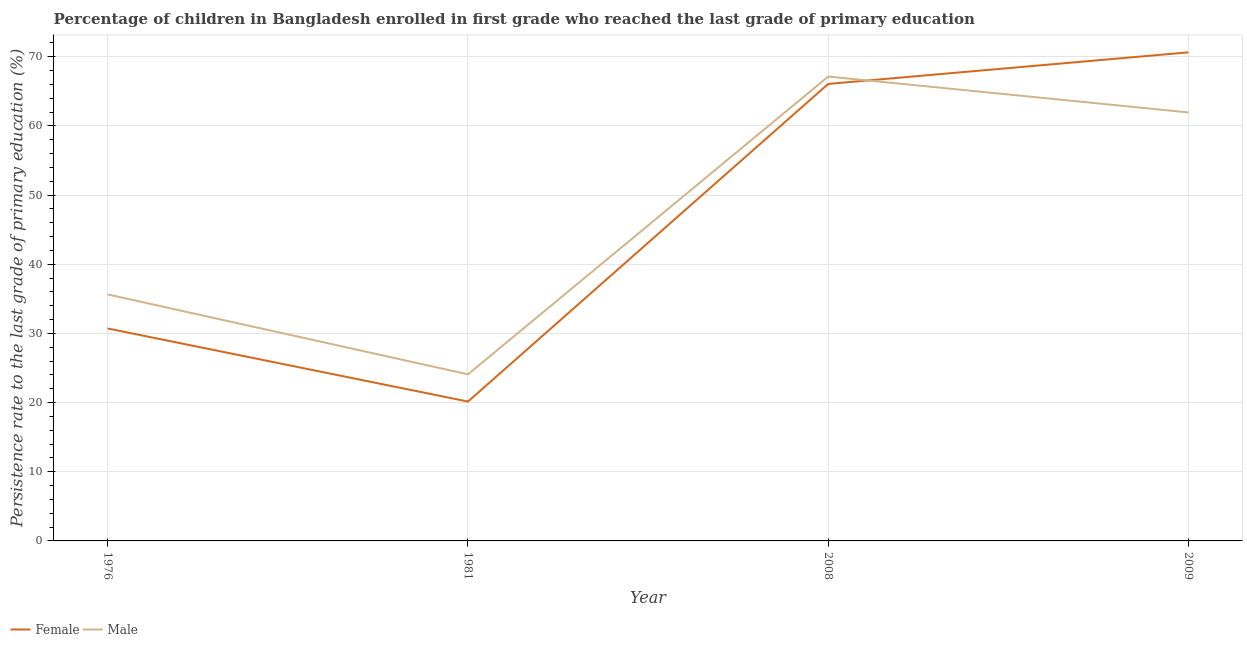How many different coloured lines are there?
Provide a succinct answer. 2. Does the line corresponding to persistence rate of male students intersect with the line corresponding to persistence rate of female students?
Your answer should be compact. Yes. What is the persistence rate of male students in 2008?
Offer a terse response. 67.14. Across all years, what is the maximum persistence rate of male students?
Your answer should be compact. 67.14. Across all years, what is the minimum persistence rate of male students?
Offer a terse response. 24.09. In which year was the persistence rate of male students maximum?
Make the answer very short. 2008. What is the total persistence rate of female students in the graph?
Keep it short and to the point. 187.57. What is the difference between the persistence rate of female students in 1976 and that in 1981?
Your answer should be very brief. 10.57. What is the difference between the persistence rate of female students in 1976 and the persistence rate of male students in 2008?
Your answer should be very brief. -36.42. What is the average persistence rate of female students per year?
Offer a terse response. 46.89. In the year 2008, what is the difference between the persistence rate of male students and persistence rate of female students?
Make the answer very short. 1.07. What is the ratio of the persistence rate of male students in 1976 to that in 1981?
Your response must be concise. 1.48. What is the difference between the highest and the second highest persistence rate of male students?
Provide a succinct answer. 5.19. What is the difference between the highest and the lowest persistence rate of male students?
Your answer should be compact. 43.05. Is the sum of the persistence rate of male students in 1976 and 2008 greater than the maximum persistence rate of female students across all years?
Your answer should be compact. Yes. Is the persistence rate of female students strictly greater than the persistence rate of male students over the years?
Your response must be concise. No. Where does the legend appear in the graph?
Offer a very short reply. Bottom left. How many legend labels are there?
Keep it short and to the point. 2. What is the title of the graph?
Offer a terse response. Percentage of children in Bangladesh enrolled in first grade who reached the last grade of primary education. Does "Malaria" appear as one of the legend labels in the graph?
Ensure brevity in your answer.  No. What is the label or title of the Y-axis?
Provide a short and direct response. Persistence rate to the last grade of primary education (%). What is the Persistence rate to the last grade of primary education (%) in Female in 1976?
Provide a short and direct response. 30.71. What is the Persistence rate to the last grade of primary education (%) of Male in 1976?
Ensure brevity in your answer.  35.64. What is the Persistence rate to the last grade of primary education (%) in Female in 1981?
Give a very brief answer. 20.15. What is the Persistence rate to the last grade of primary education (%) in Male in 1981?
Provide a succinct answer. 24.09. What is the Persistence rate to the last grade of primary education (%) in Female in 2008?
Your answer should be compact. 66.07. What is the Persistence rate to the last grade of primary education (%) of Male in 2008?
Make the answer very short. 67.14. What is the Persistence rate to the last grade of primary education (%) of Female in 2009?
Ensure brevity in your answer.  70.64. What is the Persistence rate to the last grade of primary education (%) of Male in 2009?
Offer a very short reply. 61.95. Across all years, what is the maximum Persistence rate to the last grade of primary education (%) of Female?
Your answer should be very brief. 70.64. Across all years, what is the maximum Persistence rate to the last grade of primary education (%) in Male?
Keep it short and to the point. 67.14. Across all years, what is the minimum Persistence rate to the last grade of primary education (%) of Female?
Provide a succinct answer. 20.15. Across all years, what is the minimum Persistence rate to the last grade of primary education (%) of Male?
Give a very brief answer. 24.09. What is the total Persistence rate to the last grade of primary education (%) in Female in the graph?
Ensure brevity in your answer.  187.57. What is the total Persistence rate to the last grade of primary education (%) of Male in the graph?
Ensure brevity in your answer.  188.81. What is the difference between the Persistence rate to the last grade of primary education (%) in Female in 1976 and that in 1981?
Offer a very short reply. 10.57. What is the difference between the Persistence rate to the last grade of primary education (%) in Male in 1976 and that in 1981?
Provide a succinct answer. 11.55. What is the difference between the Persistence rate to the last grade of primary education (%) in Female in 1976 and that in 2008?
Provide a succinct answer. -35.36. What is the difference between the Persistence rate to the last grade of primary education (%) of Male in 1976 and that in 2008?
Provide a short and direct response. -31.5. What is the difference between the Persistence rate to the last grade of primary education (%) in Female in 1976 and that in 2009?
Your answer should be very brief. -39.92. What is the difference between the Persistence rate to the last grade of primary education (%) of Male in 1976 and that in 2009?
Keep it short and to the point. -26.31. What is the difference between the Persistence rate to the last grade of primary education (%) of Female in 1981 and that in 2008?
Your answer should be compact. -45.92. What is the difference between the Persistence rate to the last grade of primary education (%) in Male in 1981 and that in 2008?
Keep it short and to the point. -43.05. What is the difference between the Persistence rate to the last grade of primary education (%) in Female in 1981 and that in 2009?
Keep it short and to the point. -50.49. What is the difference between the Persistence rate to the last grade of primary education (%) in Male in 1981 and that in 2009?
Offer a terse response. -37.86. What is the difference between the Persistence rate to the last grade of primary education (%) of Female in 2008 and that in 2009?
Provide a succinct answer. -4.57. What is the difference between the Persistence rate to the last grade of primary education (%) of Male in 2008 and that in 2009?
Your answer should be very brief. 5.19. What is the difference between the Persistence rate to the last grade of primary education (%) in Female in 1976 and the Persistence rate to the last grade of primary education (%) in Male in 1981?
Offer a terse response. 6.63. What is the difference between the Persistence rate to the last grade of primary education (%) in Female in 1976 and the Persistence rate to the last grade of primary education (%) in Male in 2008?
Your response must be concise. -36.42. What is the difference between the Persistence rate to the last grade of primary education (%) of Female in 1976 and the Persistence rate to the last grade of primary education (%) of Male in 2009?
Offer a terse response. -31.24. What is the difference between the Persistence rate to the last grade of primary education (%) of Female in 1981 and the Persistence rate to the last grade of primary education (%) of Male in 2008?
Offer a very short reply. -46.99. What is the difference between the Persistence rate to the last grade of primary education (%) of Female in 1981 and the Persistence rate to the last grade of primary education (%) of Male in 2009?
Your answer should be very brief. -41.8. What is the difference between the Persistence rate to the last grade of primary education (%) in Female in 2008 and the Persistence rate to the last grade of primary education (%) in Male in 2009?
Make the answer very short. 4.12. What is the average Persistence rate to the last grade of primary education (%) in Female per year?
Your response must be concise. 46.89. What is the average Persistence rate to the last grade of primary education (%) in Male per year?
Offer a terse response. 47.2. In the year 1976, what is the difference between the Persistence rate to the last grade of primary education (%) of Female and Persistence rate to the last grade of primary education (%) of Male?
Your response must be concise. -4.92. In the year 1981, what is the difference between the Persistence rate to the last grade of primary education (%) in Female and Persistence rate to the last grade of primary education (%) in Male?
Provide a succinct answer. -3.94. In the year 2008, what is the difference between the Persistence rate to the last grade of primary education (%) of Female and Persistence rate to the last grade of primary education (%) of Male?
Give a very brief answer. -1.07. In the year 2009, what is the difference between the Persistence rate to the last grade of primary education (%) of Female and Persistence rate to the last grade of primary education (%) of Male?
Provide a succinct answer. 8.69. What is the ratio of the Persistence rate to the last grade of primary education (%) of Female in 1976 to that in 1981?
Make the answer very short. 1.52. What is the ratio of the Persistence rate to the last grade of primary education (%) of Male in 1976 to that in 1981?
Make the answer very short. 1.48. What is the ratio of the Persistence rate to the last grade of primary education (%) of Female in 1976 to that in 2008?
Keep it short and to the point. 0.46. What is the ratio of the Persistence rate to the last grade of primary education (%) in Male in 1976 to that in 2008?
Keep it short and to the point. 0.53. What is the ratio of the Persistence rate to the last grade of primary education (%) in Female in 1976 to that in 2009?
Your response must be concise. 0.43. What is the ratio of the Persistence rate to the last grade of primary education (%) in Male in 1976 to that in 2009?
Your answer should be compact. 0.58. What is the ratio of the Persistence rate to the last grade of primary education (%) of Female in 1981 to that in 2008?
Provide a short and direct response. 0.3. What is the ratio of the Persistence rate to the last grade of primary education (%) in Male in 1981 to that in 2008?
Offer a terse response. 0.36. What is the ratio of the Persistence rate to the last grade of primary education (%) of Female in 1981 to that in 2009?
Keep it short and to the point. 0.29. What is the ratio of the Persistence rate to the last grade of primary education (%) of Male in 1981 to that in 2009?
Your answer should be compact. 0.39. What is the ratio of the Persistence rate to the last grade of primary education (%) of Female in 2008 to that in 2009?
Your response must be concise. 0.94. What is the ratio of the Persistence rate to the last grade of primary education (%) of Male in 2008 to that in 2009?
Provide a succinct answer. 1.08. What is the difference between the highest and the second highest Persistence rate to the last grade of primary education (%) in Female?
Offer a terse response. 4.57. What is the difference between the highest and the second highest Persistence rate to the last grade of primary education (%) in Male?
Keep it short and to the point. 5.19. What is the difference between the highest and the lowest Persistence rate to the last grade of primary education (%) in Female?
Provide a succinct answer. 50.49. What is the difference between the highest and the lowest Persistence rate to the last grade of primary education (%) of Male?
Your answer should be compact. 43.05. 